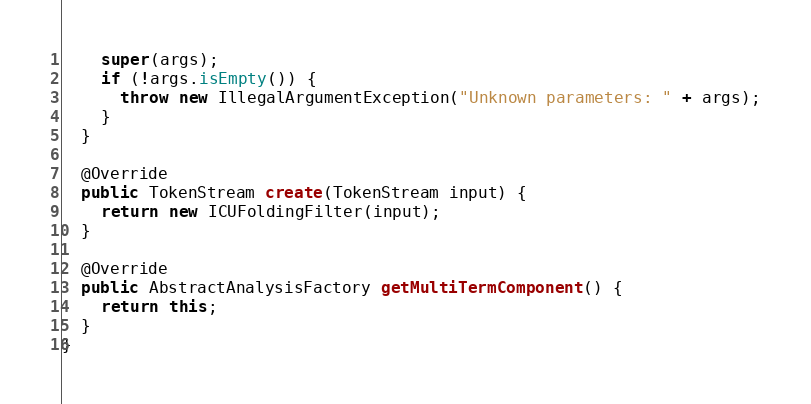Convert code to text. <code><loc_0><loc_0><loc_500><loc_500><_Java_>    super(args);
    if (!args.isEmpty()) {
      throw new IllegalArgumentException("Unknown parameters: " + args);
    }
  }

  @Override
  public TokenStream create(TokenStream input) {
    return new ICUFoldingFilter(input);
  }

  @Override
  public AbstractAnalysisFactory getMultiTermComponent() {
    return this;
  }
}
</code> 